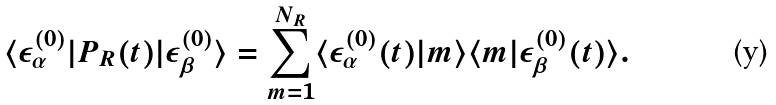<formula> <loc_0><loc_0><loc_500><loc_500>\langle \epsilon _ { \alpha } ^ { ( 0 ) } | P _ { R } ( t ) | \epsilon _ { \beta } ^ { ( 0 ) } \rangle = \sum _ { m = 1 } ^ { N _ { R } } \langle \epsilon _ { \alpha } ^ { ( 0 ) } ( t ) | m \rangle \langle m | \epsilon _ { \beta } ^ { ( 0 ) } ( t ) \rangle .</formula> 